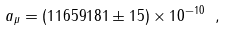<formula> <loc_0><loc_0><loc_500><loc_500>a _ { \mu } = ( 1 1 6 5 9 1 8 1 \pm 1 5 ) \times 1 0 ^ { - 1 0 } \ ,</formula> 